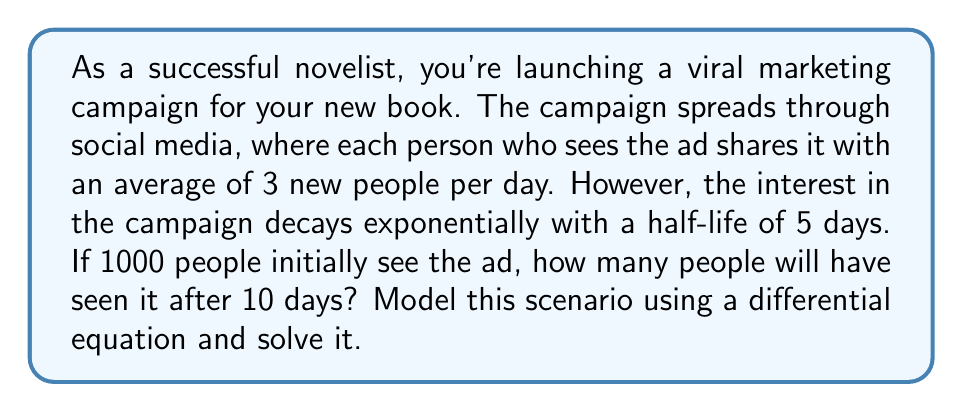Give your solution to this math problem. Let's approach this step-by-step:

1) Let $N(t)$ be the number of people who have seen the ad at time $t$ (in days).

2) The rate of change of $N$ with respect to $t$ is given by:

   $$\frac{dN}{dt} = 3N - kN$$

   where $3N$ represents the growth (3 new people per day per current viewer) and $-kN$ represents the decay.

3) To find $k$, we use the half-life formula:

   $$\frac{\ln(2)}{k} = 5$$
   $$k = \frac{\ln(2)}{5} \approx 0.1386$$

4) Our differential equation is now:

   $$\frac{dN}{dt} = 3N - 0.1386N = 2.8614N$$

5) This is a separable differential equation. Solving it:

   $$\int \frac{dN}{N} = \int 2.8614 dt$$
   $$\ln(N) = 2.8614t + C$$
   $$N = e^{2.8614t + C} = Ae^{2.8614t}$$

6) Using the initial condition $N(0) = 1000$:

   $$1000 = Ae^{2.8614 \cdot 0}$$
   $$A = 1000$$

7) Therefore, our solution is:

   $$N(t) = 1000e^{2.8614t}$$

8) To find $N(10)$:

   $$N(10) = 1000e^{2.8614 \cdot 10} \approx 1,750,997$$
Answer: 1,750,997 people 